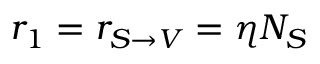<formula> <loc_0><loc_0><loc_500><loc_500>r _ { 1 } = r _ { S \rightarrow V } = \eta N _ { S }</formula> 